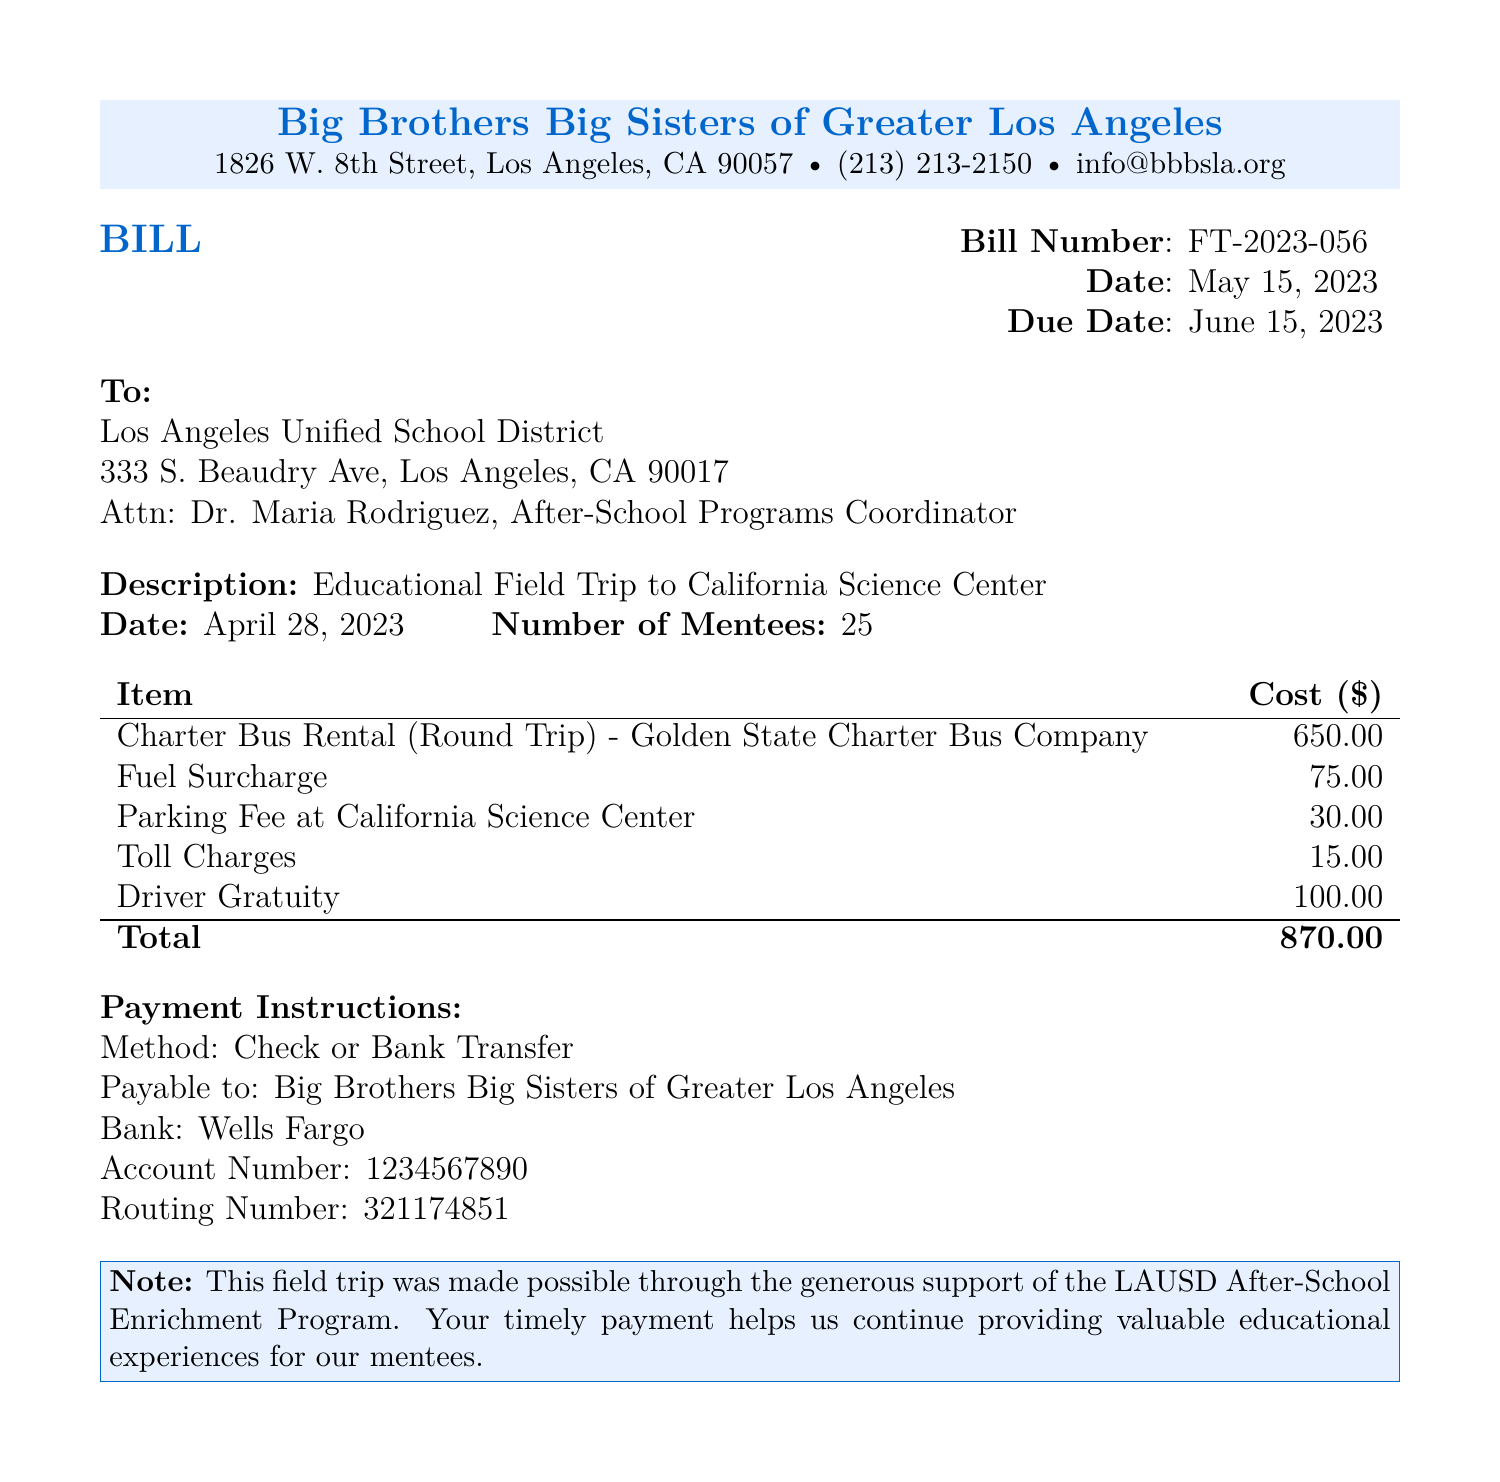what is the total cost of the bill? The total cost is listed at the bottom of the itemized section of the bill.
Answer: $870.00 what is the bill number? The bill number is specified near the top of the document.
Answer: FT-2023-056 who is the bill addressed to? The recipient of the bill is mentioned in the "To" section at the top of the document.
Answer: Los Angeles Unified School District what is the date of the educational field trip? The date of the field trip is indicated in the description section of the bill.
Answer: April 28, 2023 who provided the charter bus rental? The service provider for the transportation is mentioned in the itemized list.
Answer: Golden State Charter Bus Company when is the due date for the payment? The due date is stated next to the "Due Date" header in the bill.
Answer: June 15, 2023 how many mentees attended the trip? The number of mentees is provided in the description section of the bill.
Answer: 25 what payment methods are accepted? The payment instructions section outlines acceptable payment methods.
Answer: Check or Bank Transfer what is the parking fee listed in the document? The parking fee is detailed in the itemized cost breakdown.
Answer: $30.00 